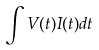Convert formula to latex. <formula><loc_0><loc_0><loc_500><loc_500>\int V ( t ) I ( t ) d t</formula> 